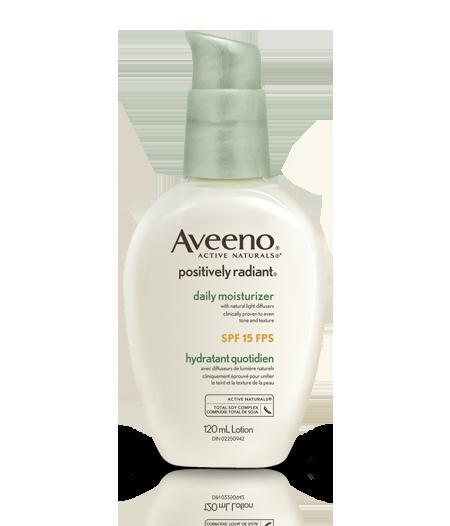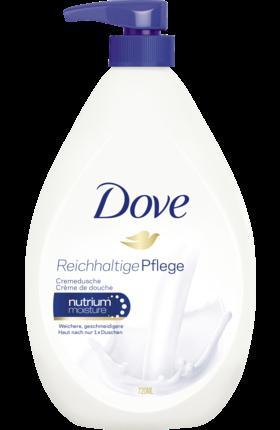The first image is the image on the left, the second image is the image on the right. Given the left and right images, does the statement "Both bottles have a pump-style dispenser on top." hold true? Answer yes or no. Yes. The first image is the image on the left, the second image is the image on the right. Analyze the images presented: Is the assertion "There is at most, 1 lotion bottle with a green cap." valid? Answer yes or no. Yes. 